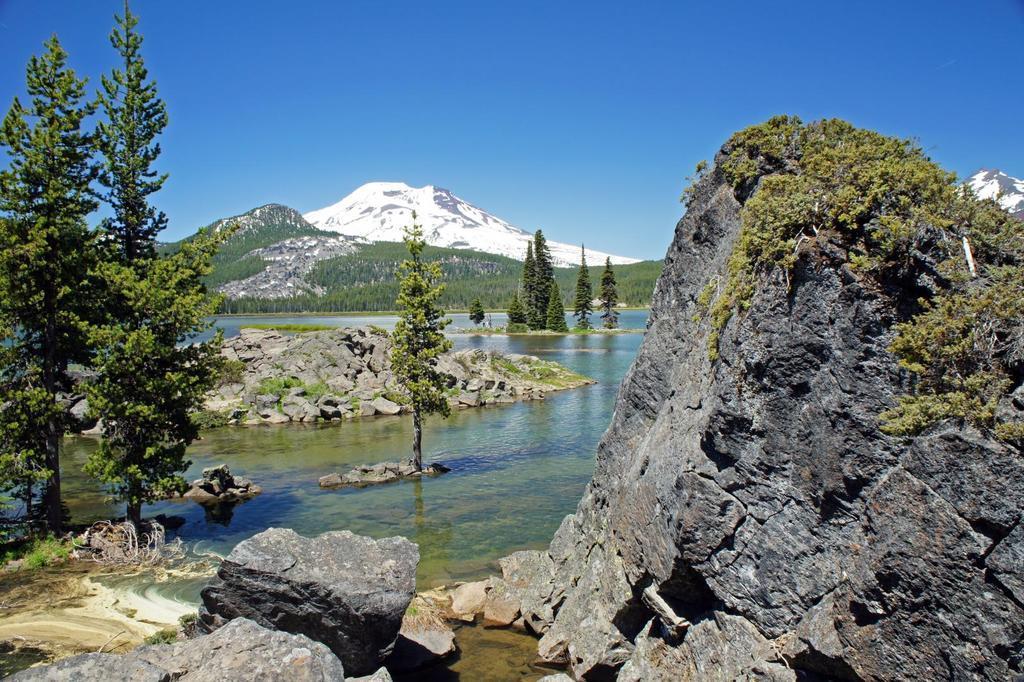In one or two sentences, can you explain what this image depicts? In this image we can see some stones, water, trees and in the background of the image there are some mountains and clear sky. 